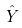<formula> <loc_0><loc_0><loc_500><loc_500>\hat { Y }</formula> 